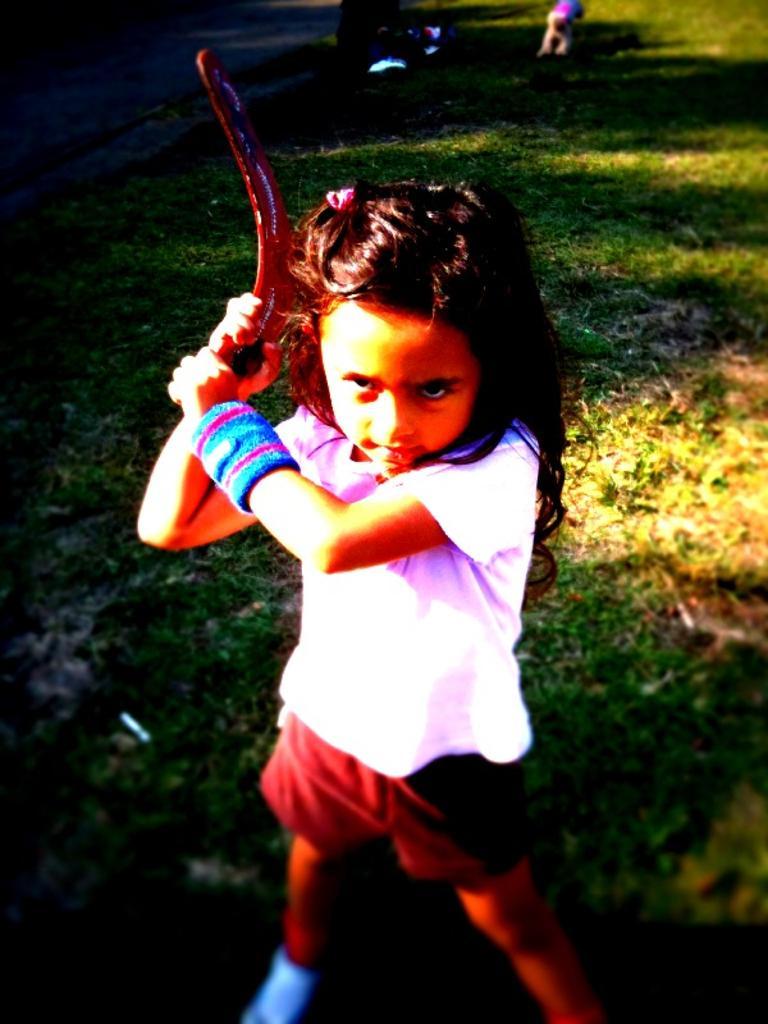Describe this image in one or two sentences. In this picture I can see a girl is wearing white color t shirt and shorts. The girl is holding an object in the hand. In the background I can see grass. 